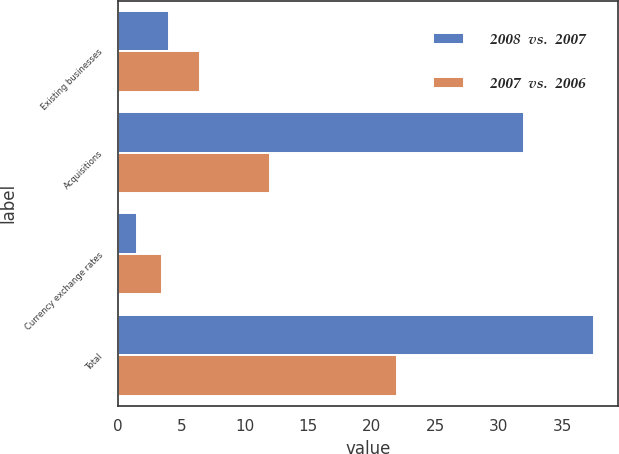Convert chart. <chart><loc_0><loc_0><loc_500><loc_500><stacked_bar_chart><ecel><fcel>Existing businesses<fcel>Acquisitions<fcel>Currency exchange rates<fcel>Total<nl><fcel>2008  vs.  2007<fcel>4<fcel>32<fcel>1.5<fcel>37.5<nl><fcel>2007  vs.  2006<fcel>6.5<fcel>12<fcel>3.5<fcel>22<nl></chart> 